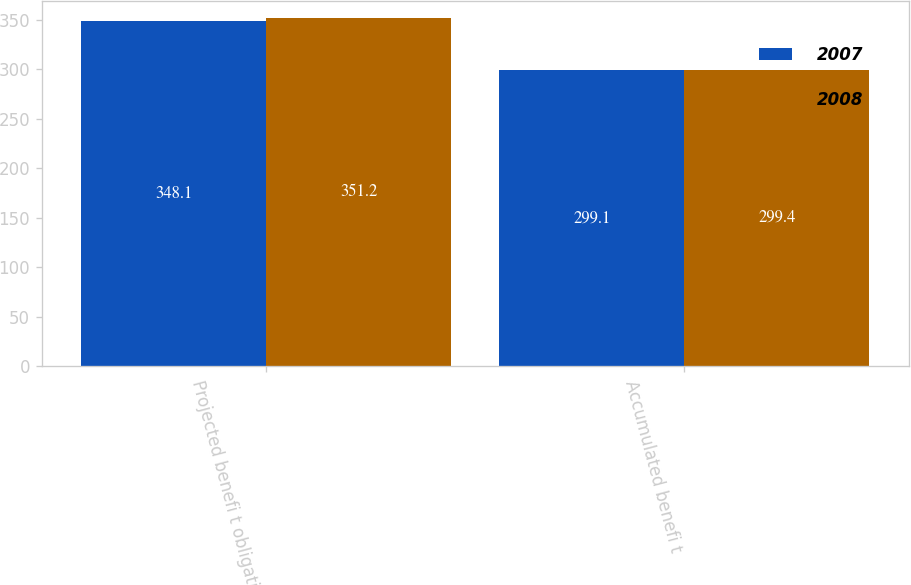Convert chart. <chart><loc_0><loc_0><loc_500><loc_500><stacked_bar_chart><ecel><fcel>Projected benefi t obligation<fcel>Accumulated benefi t<nl><fcel>2007<fcel>348.1<fcel>299.1<nl><fcel>2008<fcel>351.2<fcel>299.4<nl></chart> 